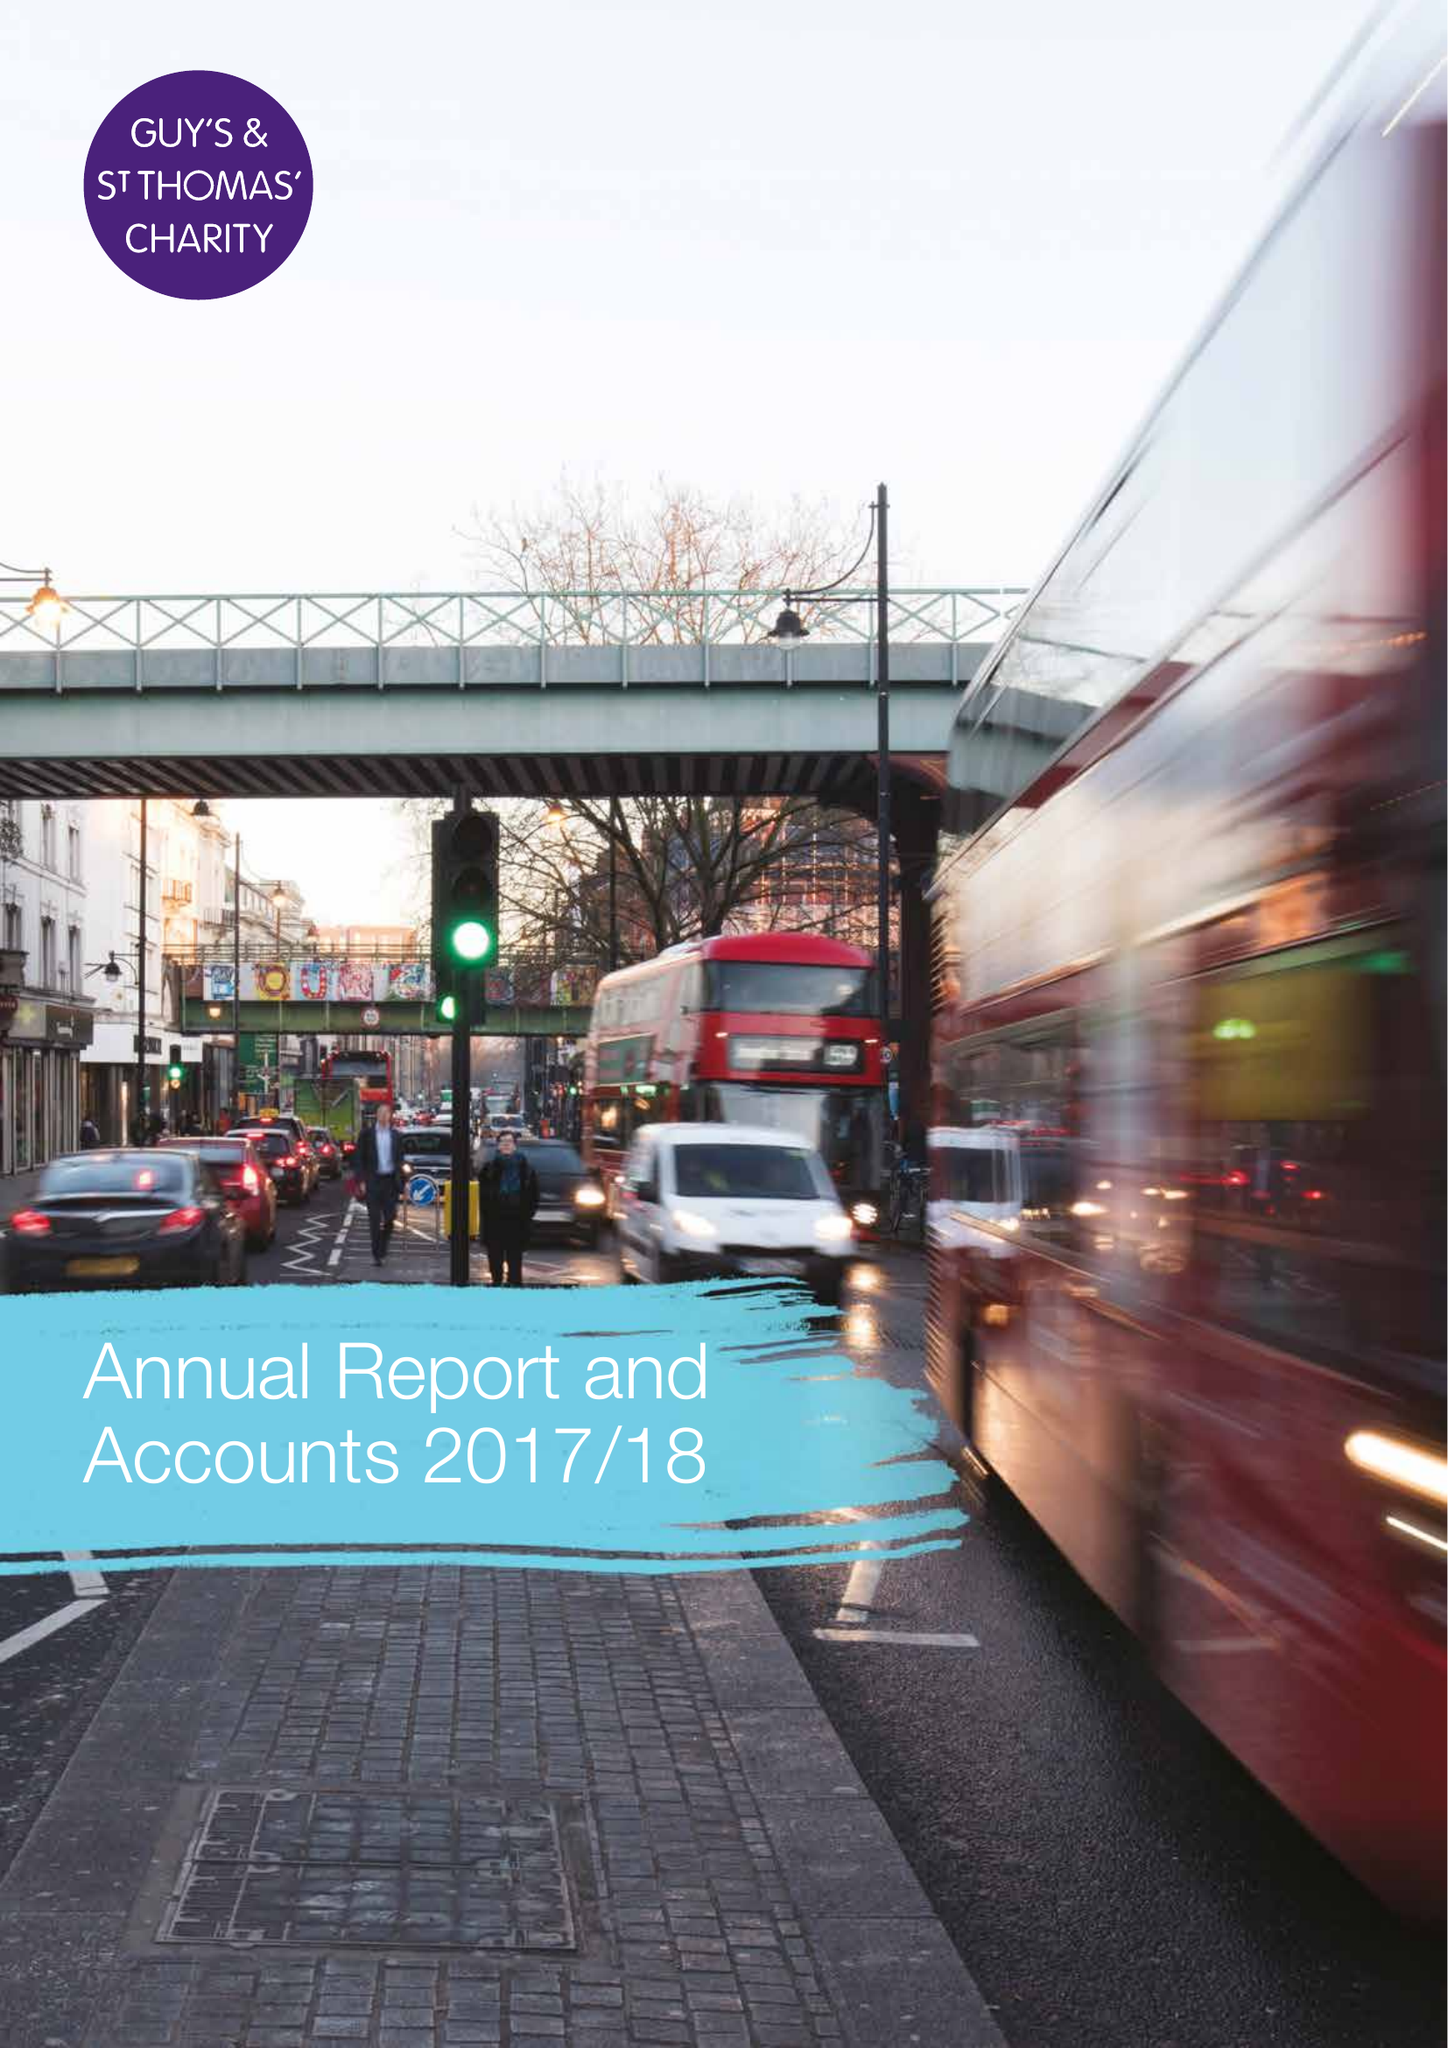What is the value for the address__street_line?
Answer the question using a single word or phrase. None 